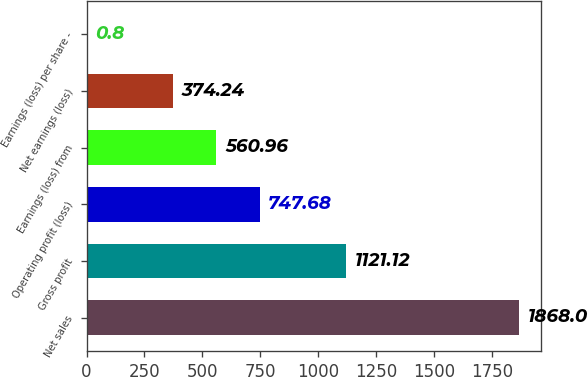Convert chart. <chart><loc_0><loc_0><loc_500><loc_500><bar_chart><fcel>Net sales<fcel>Gross profit<fcel>Operating profit (loss)<fcel>Earnings (loss) from<fcel>Net earnings (loss)<fcel>Earnings (loss) per share -<nl><fcel>1868<fcel>1121.12<fcel>747.68<fcel>560.96<fcel>374.24<fcel>0.8<nl></chart> 